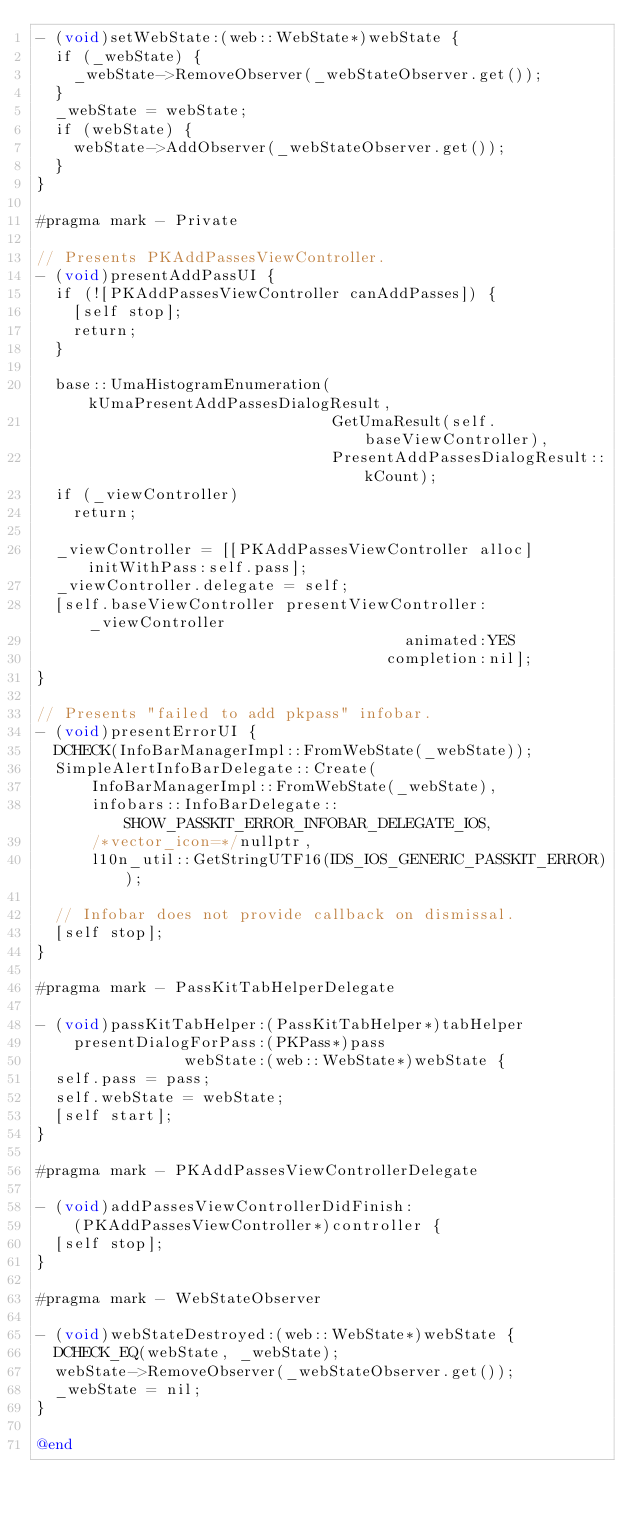<code> <loc_0><loc_0><loc_500><loc_500><_ObjectiveC_>- (void)setWebState:(web::WebState*)webState {
  if (_webState) {
    _webState->RemoveObserver(_webStateObserver.get());
  }
  _webState = webState;
  if (webState) {
    webState->AddObserver(_webStateObserver.get());
  }
}

#pragma mark - Private

// Presents PKAddPassesViewController.
- (void)presentAddPassUI {
  if (![PKAddPassesViewController canAddPasses]) {
    [self stop];
    return;
  }

  base::UmaHistogramEnumeration(kUmaPresentAddPassesDialogResult,
                                GetUmaResult(self.baseViewController),
                                PresentAddPassesDialogResult::kCount);
  if (_viewController)
    return;

  _viewController = [[PKAddPassesViewController alloc] initWithPass:self.pass];
  _viewController.delegate = self;
  [self.baseViewController presentViewController:_viewController
                                        animated:YES
                                      completion:nil];
}

// Presents "failed to add pkpass" infobar.
- (void)presentErrorUI {
  DCHECK(InfoBarManagerImpl::FromWebState(_webState));
  SimpleAlertInfoBarDelegate::Create(
      InfoBarManagerImpl::FromWebState(_webState),
      infobars::InfoBarDelegate::SHOW_PASSKIT_ERROR_INFOBAR_DELEGATE_IOS,
      /*vector_icon=*/nullptr,
      l10n_util::GetStringUTF16(IDS_IOS_GENERIC_PASSKIT_ERROR));

  // Infobar does not provide callback on dismissal.
  [self stop];
}

#pragma mark - PassKitTabHelperDelegate

- (void)passKitTabHelper:(PassKitTabHelper*)tabHelper
    presentDialogForPass:(PKPass*)pass
                webState:(web::WebState*)webState {
  self.pass = pass;
  self.webState = webState;
  [self start];
}

#pragma mark - PKAddPassesViewControllerDelegate

- (void)addPassesViewControllerDidFinish:
    (PKAddPassesViewController*)controller {
  [self stop];
}

#pragma mark - WebStateObserver

- (void)webStateDestroyed:(web::WebState*)webState {
  DCHECK_EQ(webState, _webState);
  webState->RemoveObserver(_webStateObserver.get());
  _webState = nil;
}

@end
</code> 